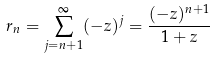Convert formula to latex. <formula><loc_0><loc_0><loc_500><loc_500>r _ { n } = \sum _ { j = n + 1 } ^ { \infty } ( - z ) ^ { j } = \frac { ( - z ) ^ { n + 1 } } { 1 + z }</formula> 